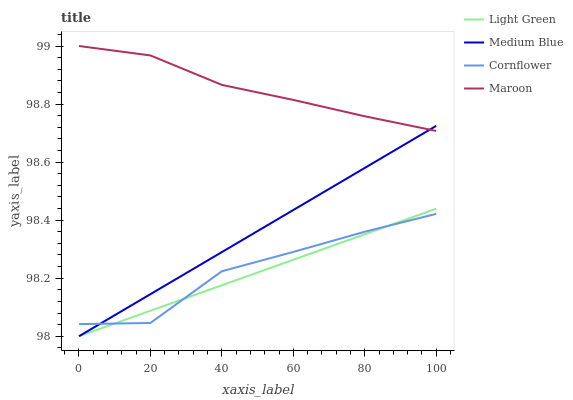Does Light Green have the minimum area under the curve?
Answer yes or no. Yes. Does Maroon have the maximum area under the curve?
Answer yes or no. Yes. Does Medium Blue have the minimum area under the curve?
Answer yes or no. No. Does Medium Blue have the maximum area under the curve?
Answer yes or no. No. Is Light Green the smoothest?
Answer yes or no. Yes. Is Cornflower the roughest?
Answer yes or no. Yes. Is Medium Blue the smoothest?
Answer yes or no. No. Is Medium Blue the roughest?
Answer yes or no. No. Does Medium Blue have the lowest value?
Answer yes or no. Yes. Does Maroon have the lowest value?
Answer yes or no. No. Does Maroon have the highest value?
Answer yes or no. Yes. Does Medium Blue have the highest value?
Answer yes or no. No. Is Cornflower less than Maroon?
Answer yes or no. Yes. Is Maroon greater than Cornflower?
Answer yes or no. Yes. Does Medium Blue intersect Light Green?
Answer yes or no. Yes. Is Medium Blue less than Light Green?
Answer yes or no. No. Is Medium Blue greater than Light Green?
Answer yes or no. No. Does Cornflower intersect Maroon?
Answer yes or no. No. 